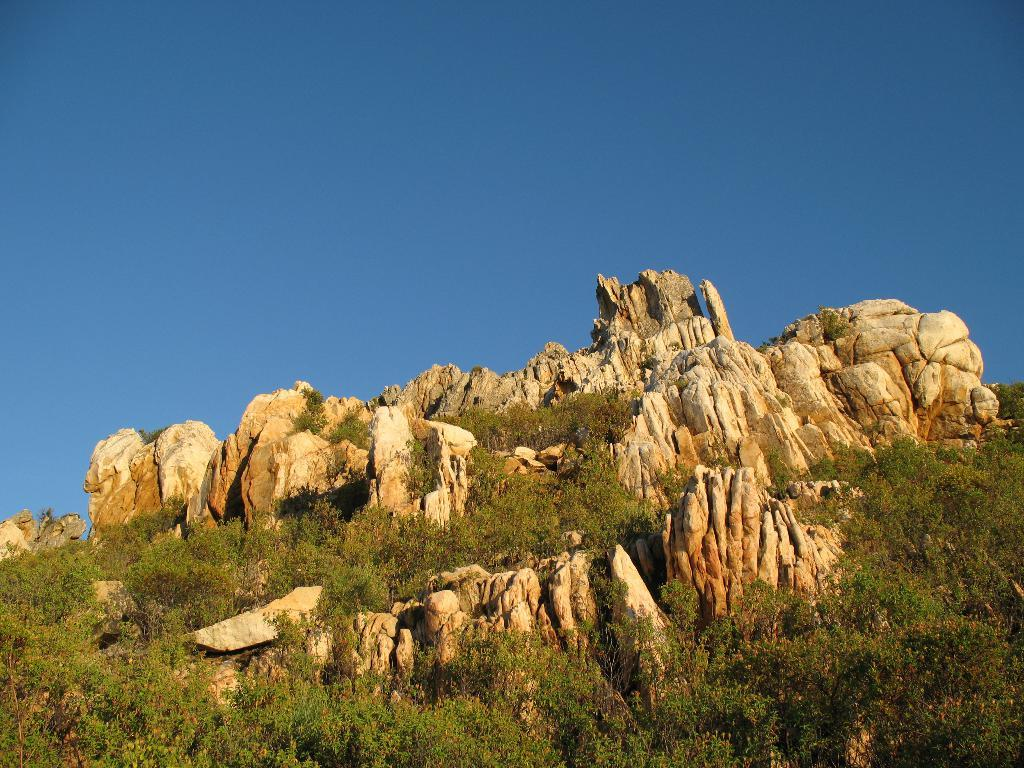What type of landform is present in the image? There is a hill in the image. What type of vegetation can be seen in the image? There are trees in the image. What color is the sky in the image? The sky is blue at the top of the image. Can you tell me how many chances the maid's son has in the image? There is no maid or son present in the image, so it is not possible to determine the number of chances they might have. 